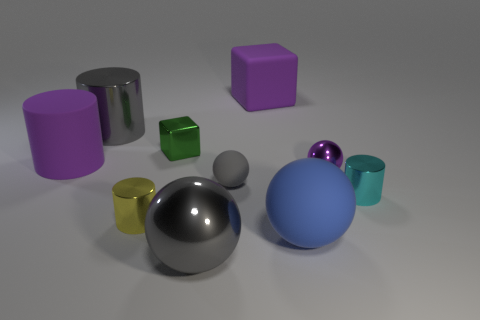What is the shape of the purple thing that is in front of the large gray shiny cylinder and left of the tiny purple thing?
Offer a very short reply. Cylinder. What color is the other large metal thing that is the same shape as the yellow metallic thing?
Give a very brief answer. Gray. Is there anything else of the same color as the big metal sphere?
Offer a terse response. Yes. There is a big gray object that is on the right side of the large gray thing that is behind the purple rubber object that is in front of the gray cylinder; what is its shape?
Give a very brief answer. Sphere. Is the size of the matte sphere that is in front of the cyan cylinder the same as the rubber object that is left of the yellow thing?
Offer a terse response. Yes. What number of yellow objects have the same material as the big blue sphere?
Provide a succinct answer. 0. What number of things are right of the rubber object that is to the left of the big metallic object to the left of the big gray shiny ball?
Provide a succinct answer. 9. Does the large blue rubber object have the same shape as the small matte object?
Provide a short and direct response. Yes. Are there any blue rubber objects that have the same shape as the purple metal object?
Offer a terse response. Yes. There is a metallic thing that is the same size as the gray shiny cylinder; what is its shape?
Your answer should be compact. Sphere. 